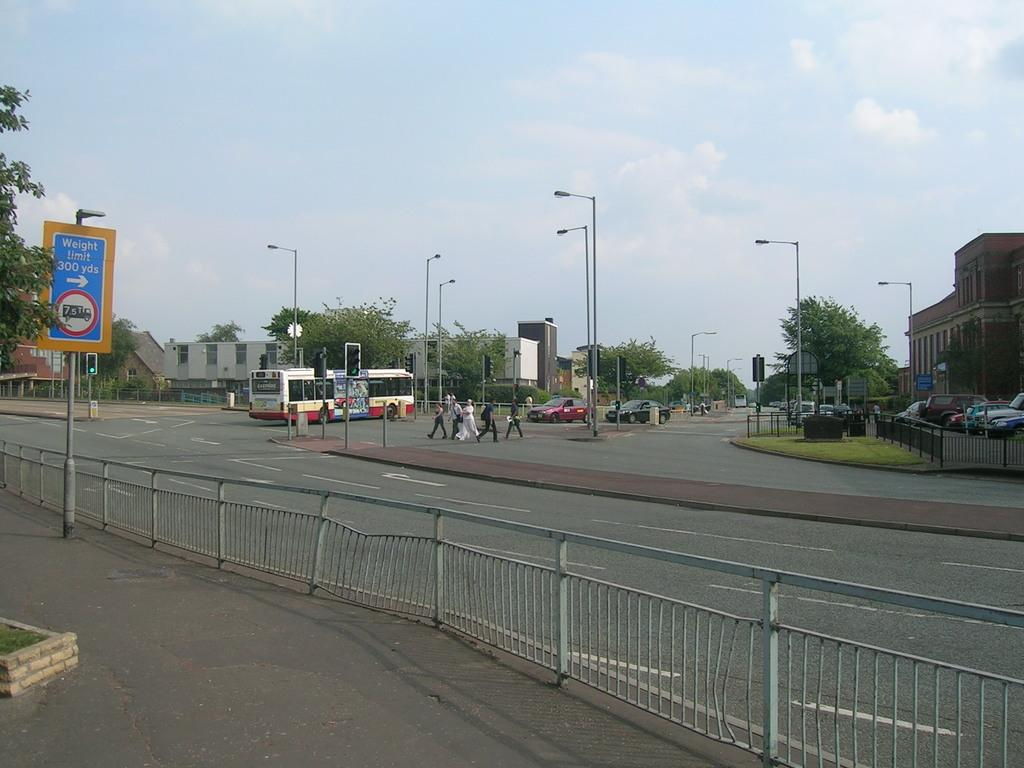<image>
Render a clear and concise summary of the photo. A blue sign that says weight limit 300 yds with an arrow pointing to the right. 